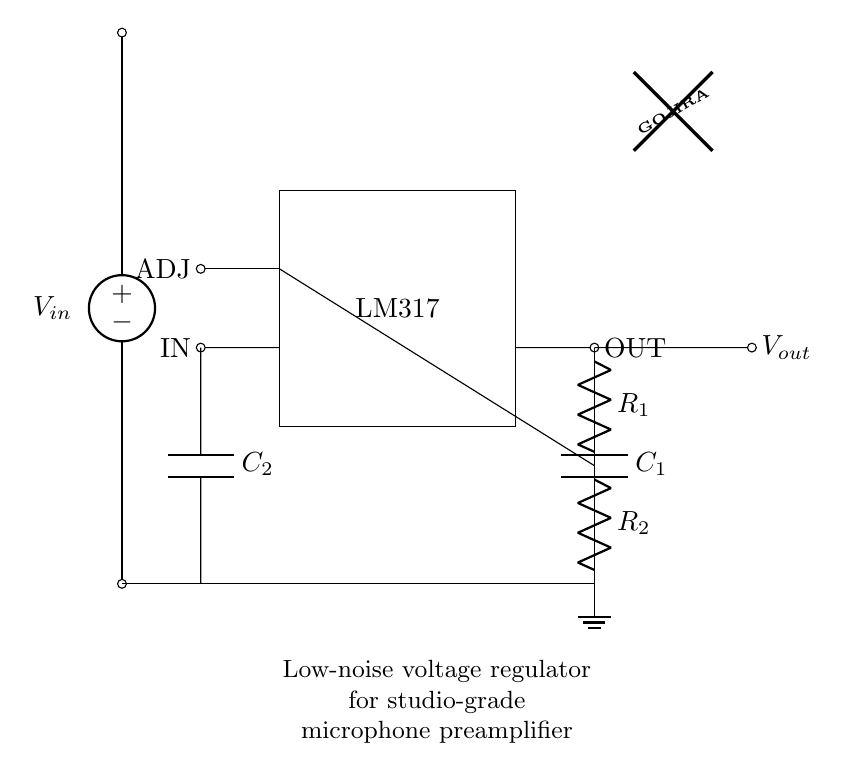What is the voltage input of this circuit? The voltage input is denoted as V_in, which is the potential difference supplied to the circuit.
Answer: V_in What component is represented by the rectangle labeled 'LM317'? The LM317 is a voltage regulator integrated circuit, which is responsible for regulating the output voltage.
Answer: LM317 What is the purpose of the capacitors C1 and C2 in this circuit? Capacitors C1 and C2 help stabilize the voltage output and filter noise, respectively, improving the overall performance of the microphone preamplifier.
Answer: Stabilization and filtering How many resistors are present in the feedback network? There are two resistors in the feedback network, labeled R1 and R2, which are used to set the output voltage.
Answer: Two What is the output node of the regulator? The output node is labeled as V_out, which indicates the regulated voltage provided by the LM317 to the connected load.
Answer: V_out How does the feedback network affect the output voltage? The feedback network, consisting of R1 and R2, forms a voltage divider that adjusts the output voltage back to the ADJ pin, allowing the regulator to maintain a constant output despite varying input voltages.
Answer: Through voltage division What is the significance of using a low-noise regulator in this circuit? A low-noise regulator minimizes electrical noise, which is crucial in a microphone preamplifier to preserve audio quality and ensure clear sound reproduction.
Answer: Preserving audio quality 